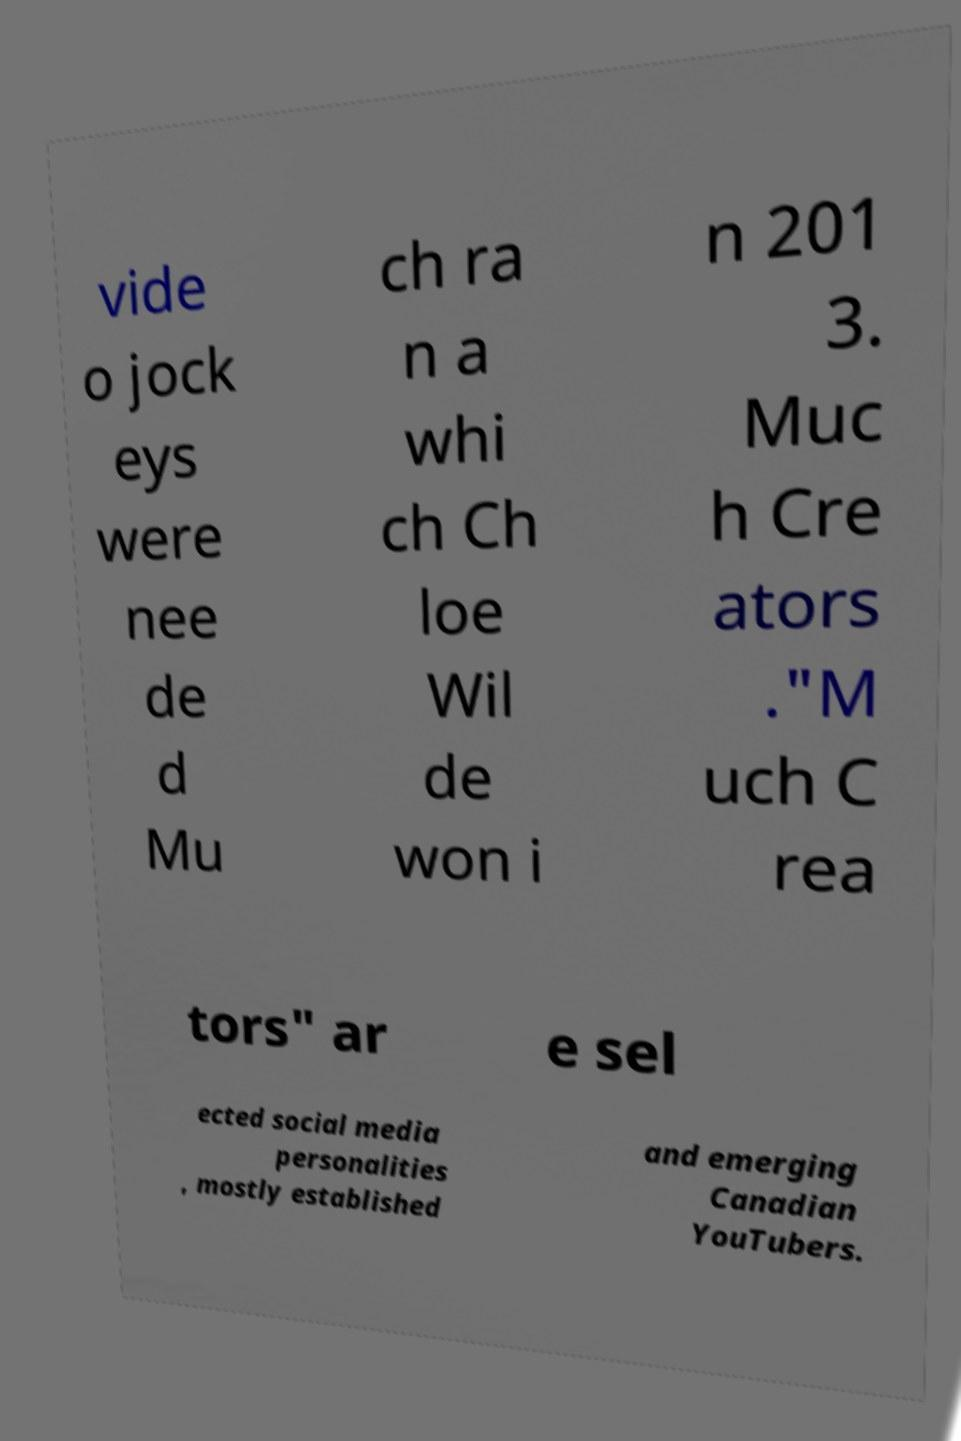Please identify and transcribe the text found in this image. vide o jock eys were nee de d Mu ch ra n a whi ch Ch loe Wil de won i n 201 3. Muc h Cre ators ."M uch C rea tors" ar e sel ected social media personalities , mostly established and emerging Canadian YouTubers. 